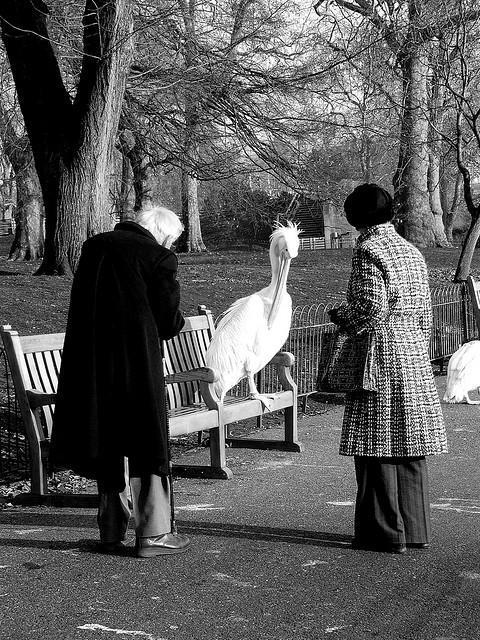What is the bird on the bench called? pelican 